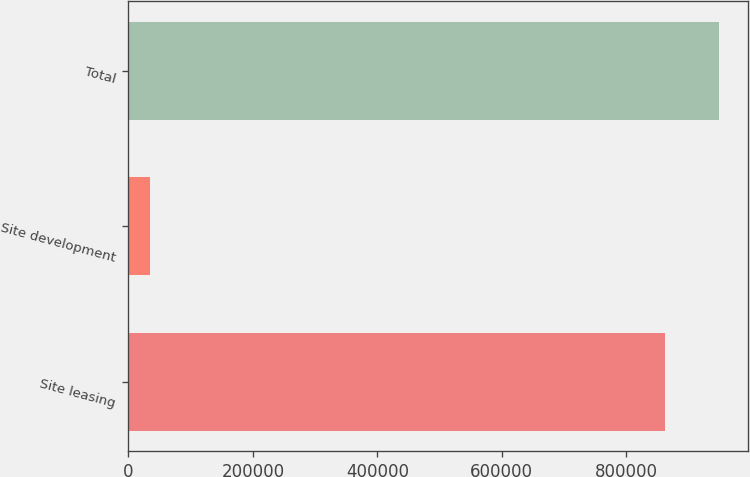Convert chart. <chart><loc_0><loc_0><loc_500><loc_500><bar_chart><fcel>Site leasing<fcel>Site development<fcel>Total<nl><fcel>862241<fcel>34372<fcel>948465<nl></chart> 